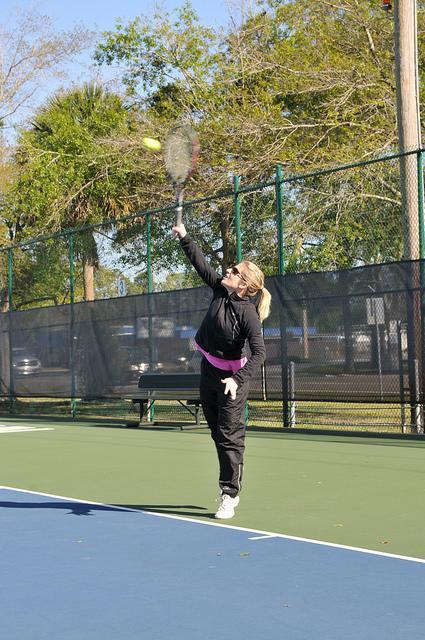How many cat tails are visible in the image?
Give a very brief answer. 0. 